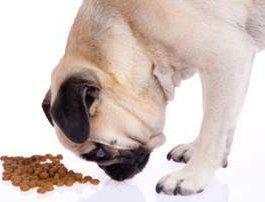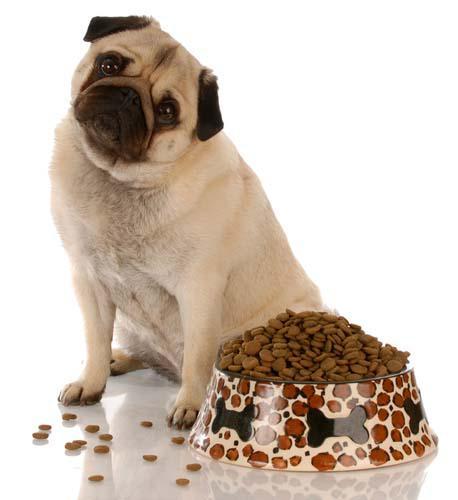The first image is the image on the left, the second image is the image on the right. Evaluate the accuracy of this statement regarding the images: "One dog is standing with his face bent down in a bowl, and the other dog is looking at the camera.". Is it true? Answer yes or no. No. The first image is the image on the left, the second image is the image on the right. Examine the images to the left and right. Is the description "In one of the images there is one dog and one round silver dog food dish." accurate? Answer yes or no. No. 